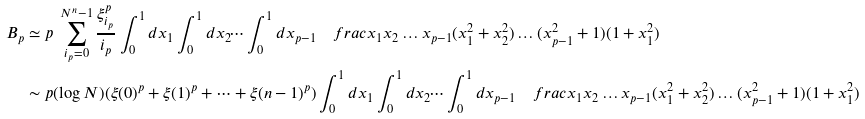Convert formula to latex. <formula><loc_0><loc_0><loc_500><loc_500>B _ { p } & \simeq p \ \sum _ { i _ { p } = 0 } ^ { N ^ { n } - 1 } \frac { \xi _ { i _ { p } } ^ { p } } { i _ { p } } \int _ { 0 } ^ { 1 } d x _ { 1 } \int _ { 0 } ^ { 1 } d x _ { 2 } \dots \int ^ { 1 } _ { 0 } d x _ { p - 1 } \quad f r a c { x _ { 1 } x _ { 2 } \dots x _ { p - 1 } } { ( x _ { 1 } ^ { 2 } + x _ { 2 } ^ { 2 } ) \dots ( x _ { p - 1 } ^ { 2 } + 1 ) ( 1 + x _ { 1 } ^ { 2 } ) } \\ & \sim p ( \log N ) ( \xi ( 0 ) ^ { p } + \xi ( 1 ) ^ { p } + \dots + \xi ( n - 1 ) ^ { p } ) \int _ { 0 } ^ { 1 } d x _ { 1 } \int _ { 0 } ^ { 1 } d x _ { 2 } \dots \int ^ { 1 } _ { 0 } d x _ { p - 1 } \quad f r a c { x _ { 1 } x _ { 2 } \dots x _ { p - 1 } } { ( x _ { 1 } ^ { 2 } + x _ { 2 } ^ { 2 } ) \dots ( x _ { p - 1 } ^ { 2 } + 1 ) ( 1 + x _ { 1 } ^ { 2 } ) }</formula> 